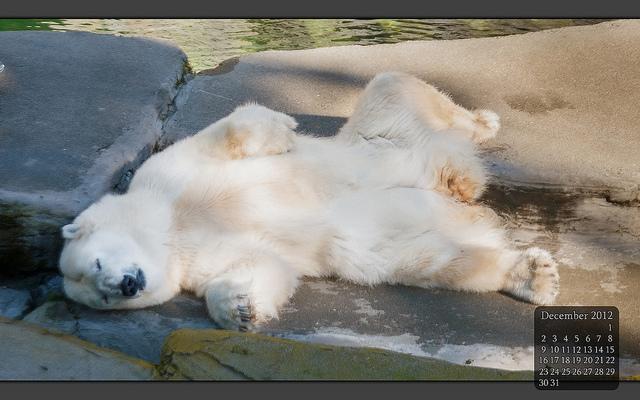What color is the sleeping animal?
Write a very short answer. White. What type of animal is this?
Concise answer only. Polar bear. Do these creatures live at the north or south pole?
Short answer required. North. Is this animal in it's natural habitat?
Give a very brief answer. No. What is underneath the bear's head?
Write a very short answer. Rock. 